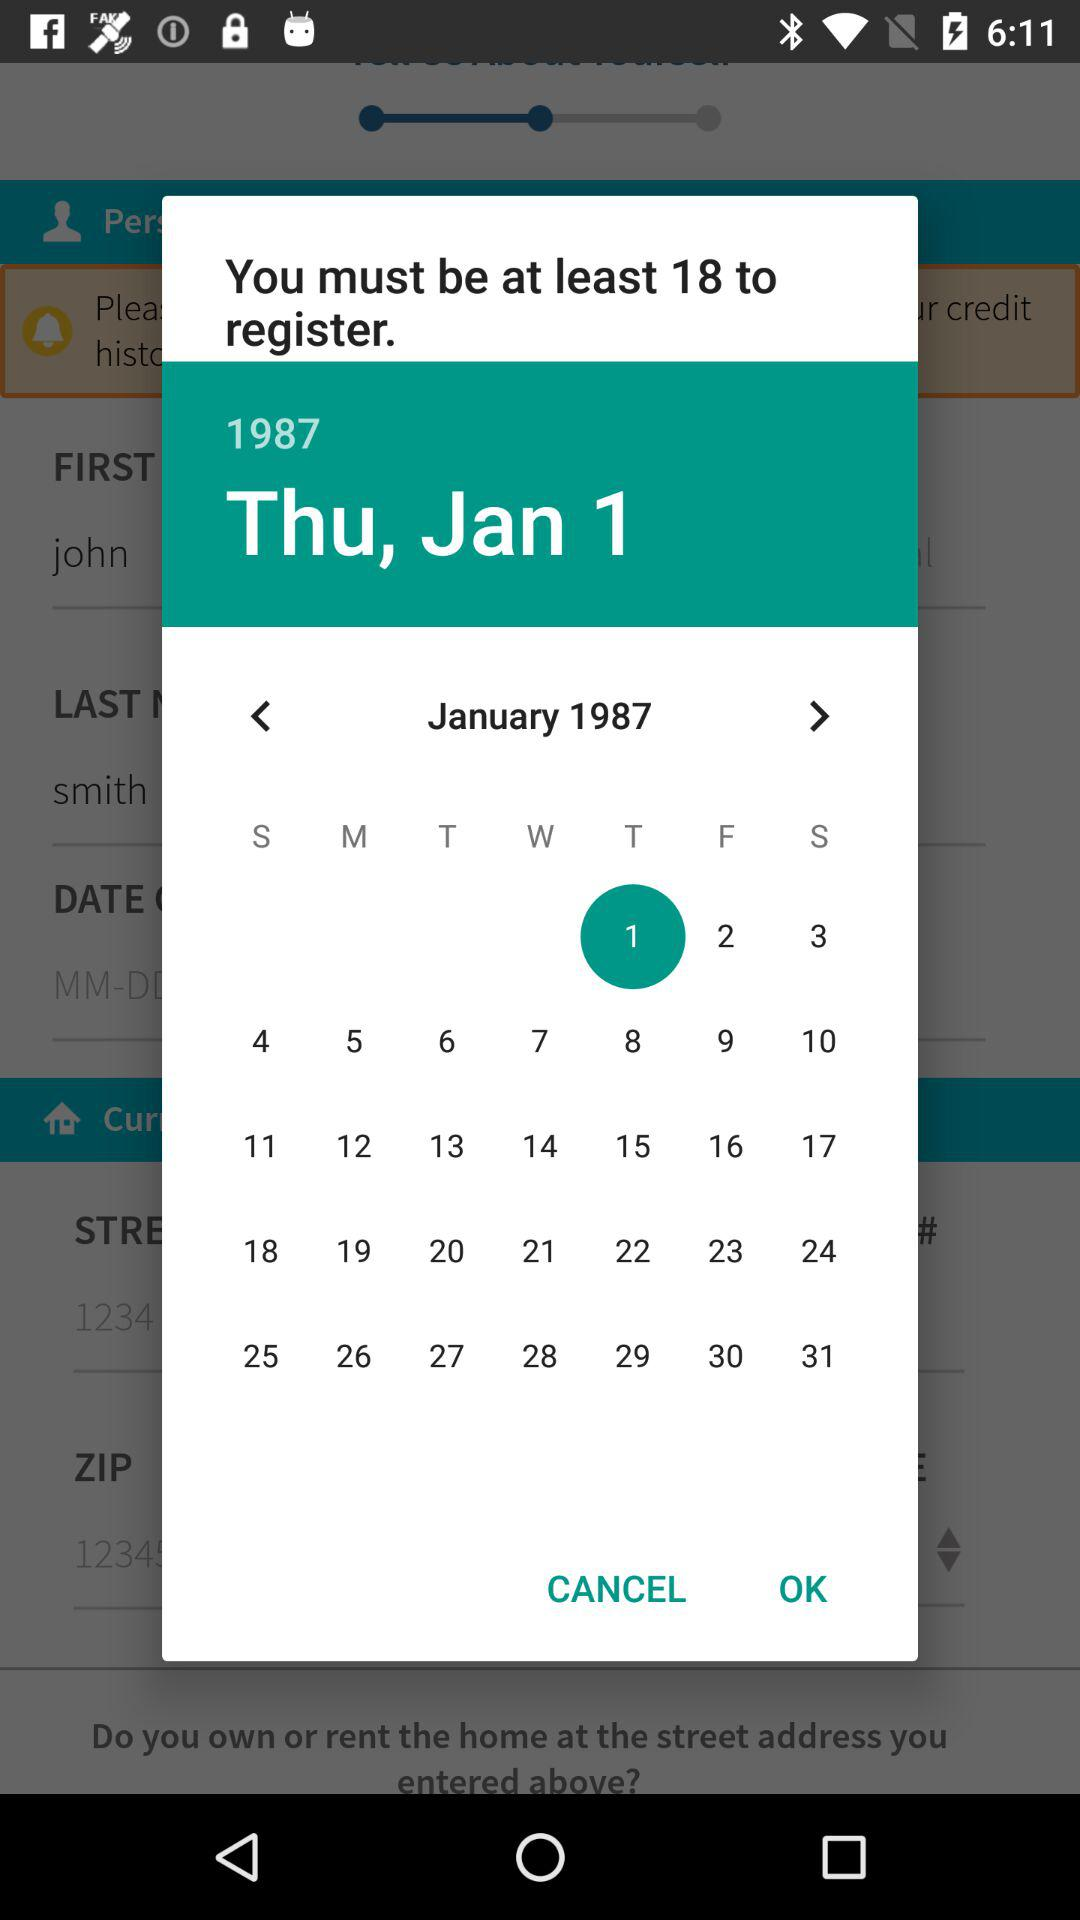What's the age limit for registration? The age limit for registration is at least 18 years. 